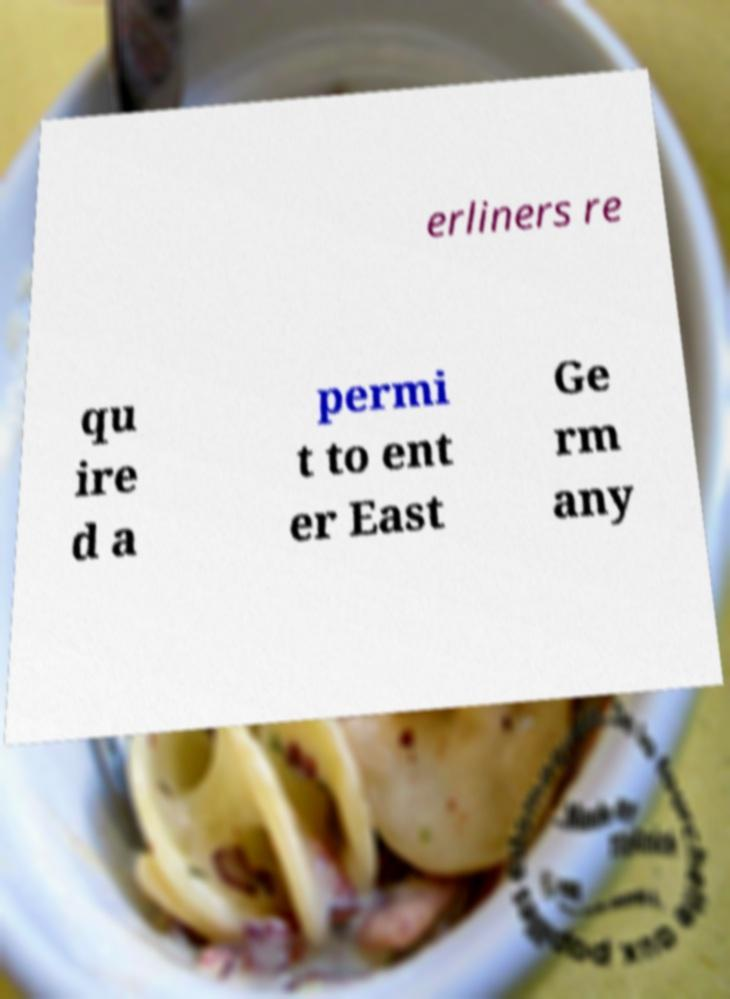Could you extract and type out the text from this image? erliners re qu ire d a permi t to ent er East Ge rm any 